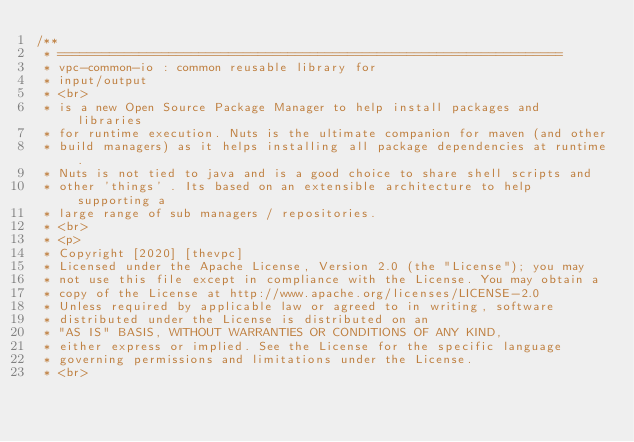<code> <loc_0><loc_0><loc_500><loc_500><_Java_>/**
 * ====================================================================
 * vpc-common-io : common reusable library for
 * input/output
 * <br>
 * is a new Open Source Package Manager to help install packages and libraries
 * for runtime execution. Nuts is the ultimate companion for maven (and other
 * build managers) as it helps installing all package dependencies at runtime.
 * Nuts is not tied to java and is a good choice to share shell scripts and
 * other 'things' . Its based on an extensible architecture to help supporting a
 * large range of sub managers / repositories.
 * <br>
 * <p>
 * Copyright [2020] [thevpc]
 * Licensed under the Apache License, Version 2.0 (the "License"); you may
 * not use this file except in compliance with the License. You may obtain a
 * copy of the License at http://www.apache.org/licenses/LICENSE-2.0
 * Unless required by applicable law or agreed to in writing, software
 * distributed under the License is distributed on an
 * "AS IS" BASIS, WITHOUT WARRANTIES OR CONDITIONS OF ANY KIND,
 * either express or implied. See the License for the specific language
 * governing permissions and limitations under the License.
 * <br></code> 